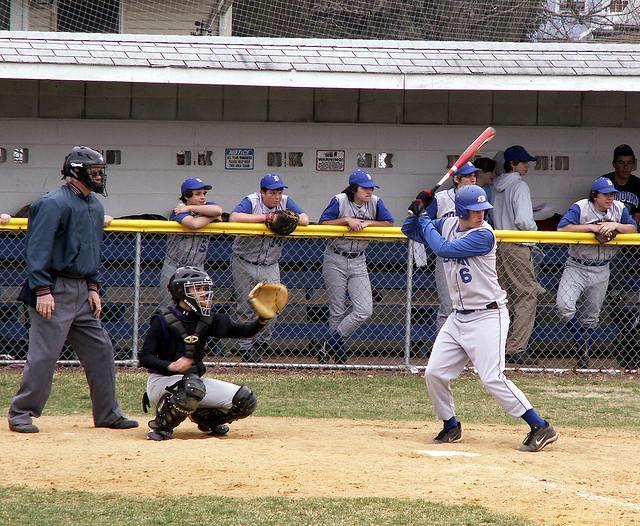How many people can you see?
Give a very brief answer. 10. 